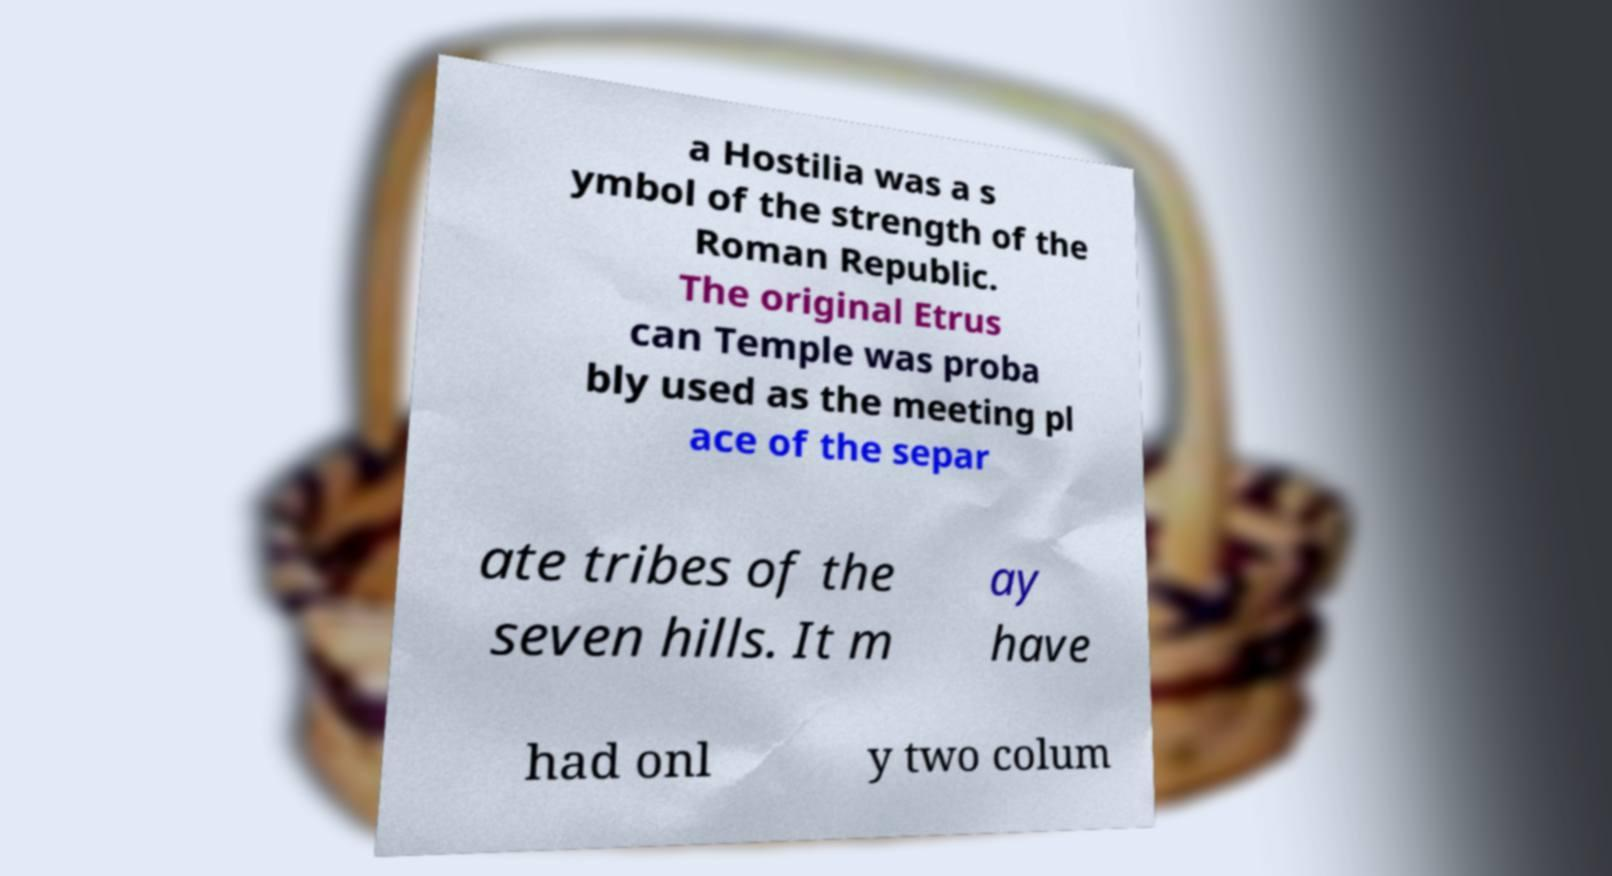Please identify and transcribe the text found in this image. a Hostilia was a s ymbol of the strength of the Roman Republic. The original Etrus can Temple was proba bly used as the meeting pl ace of the separ ate tribes of the seven hills. It m ay have had onl y two colum 